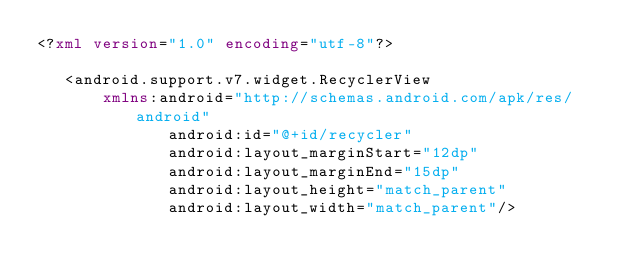Convert code to text. <code><loc_0><loc_0><loc_500><loc_500><_XML_><?xml version="1.0" encoding="utf-8"?>

   <android.support.v7.widget.RecyclerView
       xmlns:android="http://schemas.android.com/apk/res/android"
              android:id="@+id/recycler"
              android:layout_marginStart="12dp"
              android:layout_marginEnd="15dp"
              android:layout_height="match_parent"
              android:layout_width="match_parent"/>
</code> 